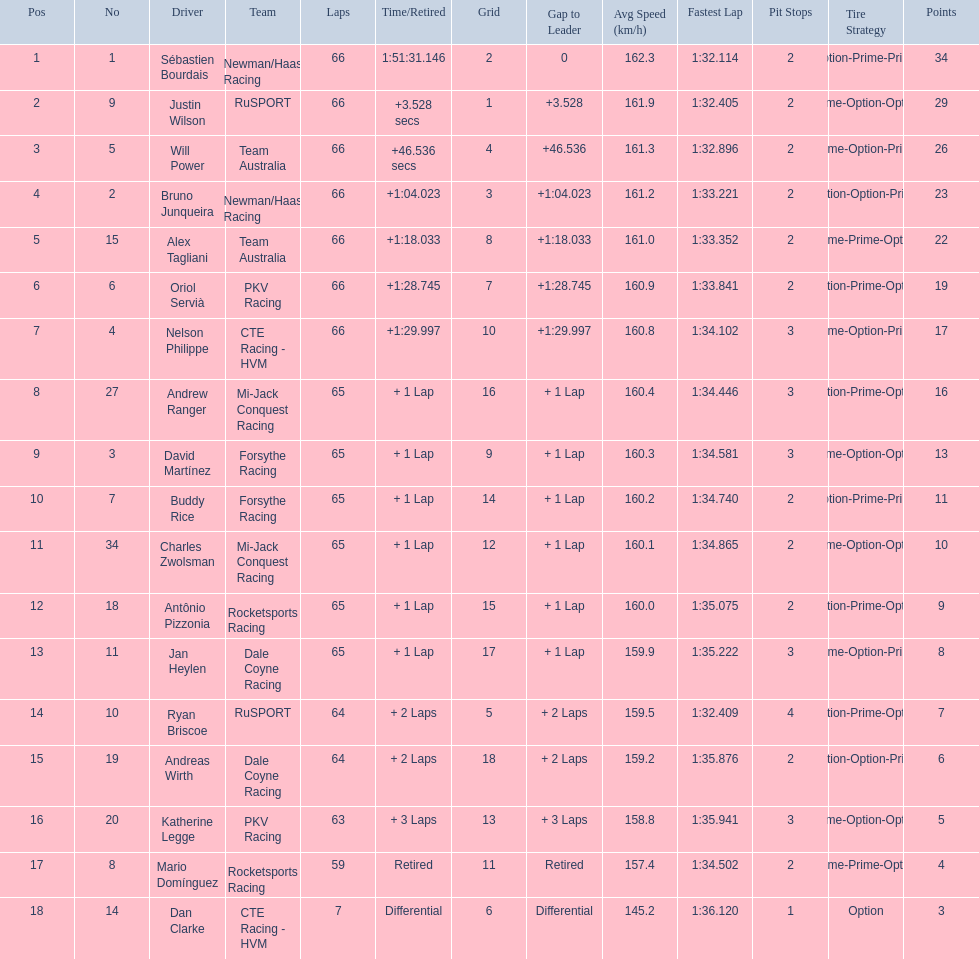Who are the drivers? Sébastien Bourdais, Justin Wilson, Will Power, Bruno Junqueira, Alex Tagliani, Oriol Servià, Nelson Philippe, Andrew Ranger, David Martínez, Buddy Rice, Charles Zwolsman, Antônio Pizzonia, Jan Heylen, Ryan Briscoe, Andreas Wirth, Katherine Legge, Mario Domínguez, Dan Clarke. What are their numbers? 1, 9, 5, 2, 15, 6, 4, 27, 3, 7, 34, 18, 11, 10, 19, 20, 8, 14. What are their positions? 1, 2, 3, 4, 5, 6, 7, 8, 9, 10, 11, 12, 13, 14, 15, 16, 17, 18. Which driver has the same number and position? Sébastien Bourdais. 